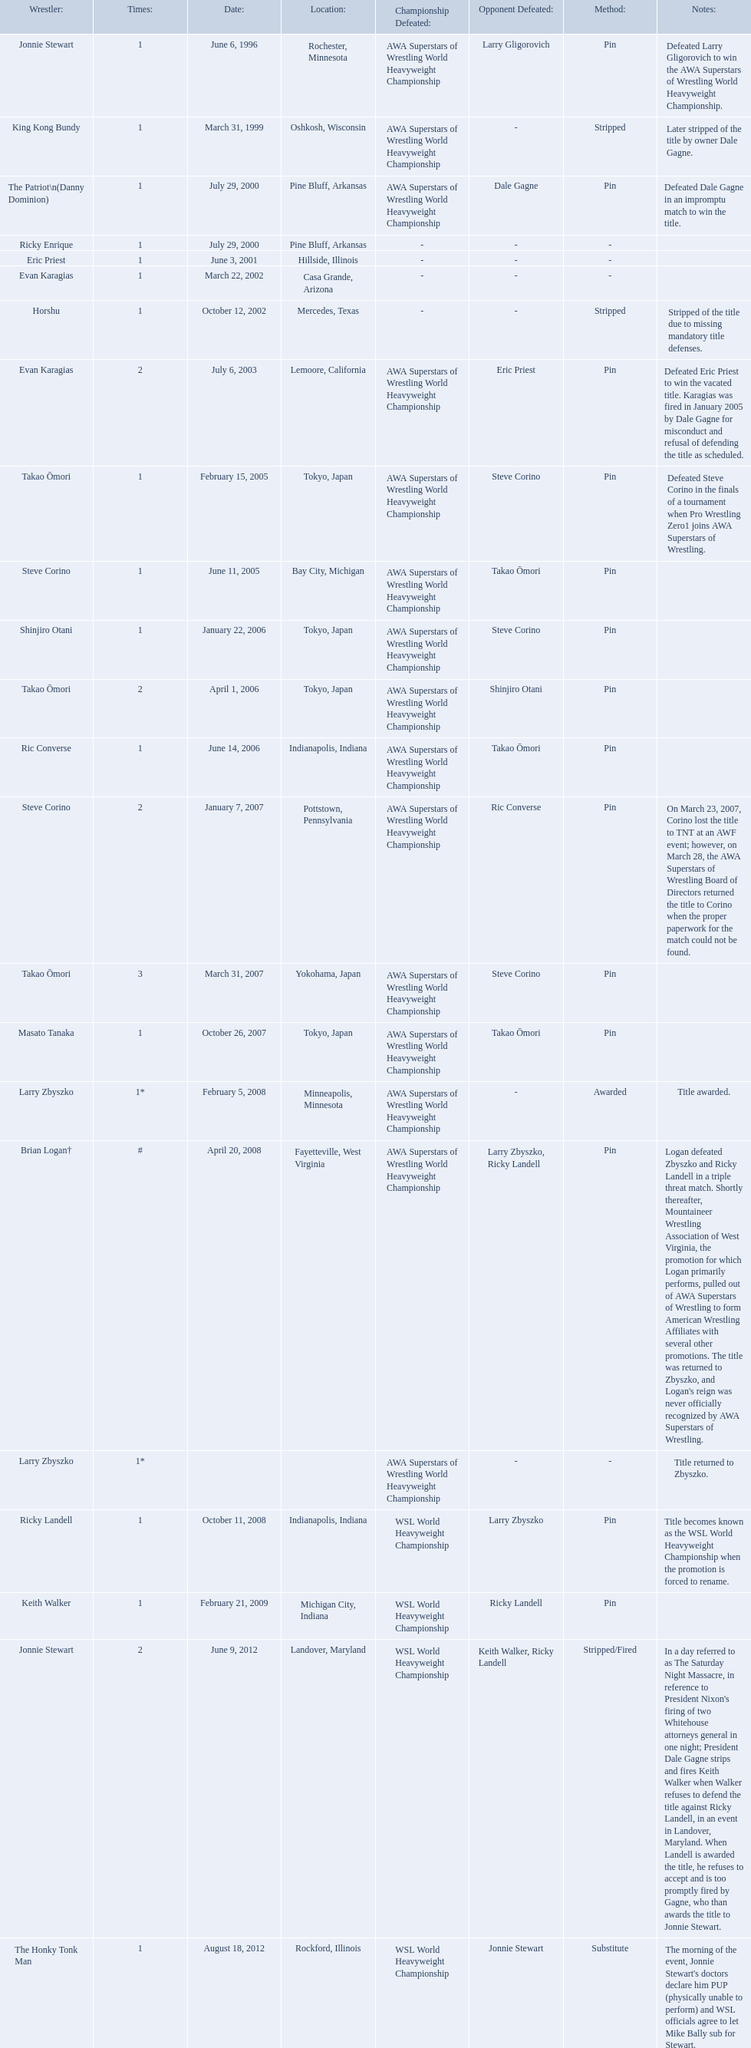Who are all of the wrestlers? Jonnie Stewart, King Kong Bundy, The Patriot\n(Danny Dominion), Ricky Enrique, Eric Priest, Evan Karagias, Horshu, Evan Karagias, Takao Ōmori, Steve Corino, Shinjiro Otani, Takao Ōmori, Ric Converse, Steve Corino, Takao Ōmori, Masato Tanaka, Larry Zbyszko, Brian Logan†, Larry Zbyszko, Ricky Landell, Keith Walker, Jonnie Stewart, The Honky Tonk Man. Where are they from? Rochester, Minnesota, Oshkosh, Wisconsin, Pine Bluff, Arkansas, Pine Bluff, Arkansas, Hillside, Illinois, Casa Grande, Arizona, Mercedes, Texas, Lemoore, California, Tokyo, Japan, Bay City, Michigan, Tokyo, Japan, Tokyo, Japan, Indianapolis, Indiana, Pottstown, Pennsylvania, Yokohama, Japan, Tokyo, Japan, Minneapolis, Minnesota, Fayetteville, West Virginia, , Indianapolis, Indiana, Michigan City, Indiana, Landover, Maryland, Rockford, Illinois. Could you help me parse every detail presented in this table? {'header': ['Wrestler:', 'Times:', 'Date:', 'Location:', 'Championship Defeated:', 'Opponent Defeated:', 'Method:', 'Notes:'], 'rows': [['Jonnie Stewart', '1', 'June 6, 1996', 'Rochester, Minnesota', 'AWA Superstars of Wrestling World Heavyweight Championship', 'Larry Gligorovich', 'Pin', 'Defeated Larry Gligorovich to win the AWA Superstars of Wrestling World Heavyweight Championship.'], ['King Kong Bundy', '1', 'March 31, 1999', 'Oshkosh, Wisconsin', 'AWA Superstars of Wrestling World Heavyweight Championship', '-', 'Stripped', 'Later stripped of the title by owner Dale Gagne.'], ['The Patriot\\n(Danny Dominion)', '1', 'July 29, 2000', 'Pine Bluff, Arkansas', 'AWA Superstars of Wrestling World Heavyweight Championship', 'Dale Gagne', 'Pin', 'Defeated Dale Gagne in an impromptu match to win the title.'], ['Ricky Enrique', '1', 'July 29, 2000', 'Pine Bluff, Arkansas', '-', '-', '-', ''], ['Eric Priest', '1', 'June 3, 2001', 'Hillside, Illinois', '-', '-', '-', ''], ['Evan Karagias', '1', 'March 22, 2002', 'Casa Grande, Arizona', '-', '-', '-', ''], ['Horshu', '1', 'October 12, 2002', 'Mercedes, Texas', '-', '-', 'Stripped', 'Stripped of the title due to missing mandatory title defenses.'], ['Evan Karagias', '2', 'July 6, 2003', 'Lemoore, California', 'AWA Superstars of Wrestling World Heavyweight Championship', 'Eric Priest', 'Pin', 'Defeated Eric Priest to win the vacated title. Karagias was fired in January 2005 by Dale Gagne for misconduct and refusal of defending the title as scheduled.'], ['Takao Ōmori', '1', 'February 15, 2005', 'Tokyo, Japan', 'AWA Superstars of Wrestling World Heavyweight Championship', 'Steve Corino', 'Pin', 'Defeated Steve Corino in the finals of a tournament when Pro Wrestling Zero1 joins AWA Superstars of Wrestling.'], ['Steve Corino', '1', 'June 11, 2005', 'Bay City, Michigan', 'AWA Superstars of Wrestling World Heavyweight Championship', 'Takao Ōmori', 'Pin', ''], ['Shinjiro Otani', '1', 'January 22, 2006', 'Tokyo, Japan', 'AWA Superstars of Wrestling World Heavyweight Championship', 'Steve Corino', 'Pin', ''], ['Takao Ōmori', '2', 'April 1, 2006', 'Tokyo, Japan', 'AWA Superstars of Wrestling World Heavyweight Championship', 'Shinjiro Otani', 'Pin', ''], ['Ric Converse', '1', 'June 14, 2006', 'Indianapolis, Indiana', 'AWA Superstars of Wrestling World Heavyweight Championship', 'Takao Ōmori', 'Pin', ''], ['Steve Corino', '2', 'January 7, 2007', 'Pottstown, Pennsylvania', 'AWA Superstars of Wrestling World Heavyweight Championship', 'Ric Converse', 'Pin', 'On March 23, 2007, Corino lost the title to TNT at an AWF event; however, on March 28, the AWA Superstars of Wrestling Board of Directors returned the title to Corino when the proper paperwork for the match could not be found.'], ['Takao Ōmori', '3', 'March 31, 2007', 'Yokohama, Japan', 'AWA Superstars of Wrestling World Heavyweight Championship', 'Steve Corino', 'Pin', ''], ['Masato Tanaka', '1', 'October 26, 2007', 'Tokyo, Japan', 'AWA Superstars of Wrestling World Heavyweight Championship', 'Takao Ōmori', 'Pin', ''], ['Larry Zbyszko', '1*', 'February 5, 2008', 'Minneapolis, Minnesota', 'AWA Superstars of Wrestling World Heavyweight Championship', '-', 'Awarded', 'Title awarded.'], ['Brian Logan†', '#', 'April 20, 2008', 'Fayetteville, West Virginia', 'AWA Superstars of Wrestling World Heavyweight Championship', 'Larry Zbyszko, Ricky Landell', 'Pin', "Logan defeated Zbyszko and Ricky Landell in a triple threat match. Shortly thereafter, Mountaineer Wrestling Association of West Virginia, the promotion for which Logan primarily performs, pulled out of AWA Superstars of Wrestling to form American Wrestling Affiliates with several other promotions. The title was returned to Zbyszko, and Logan's reign was never officially recognized by AWA Superstars of Wrestling."], ['Larry Zbyszko', '1*', '', '', 'AWA Superstars of Wrestling World Heavyweight Championship', '-', '-', 'Title returned to Zbyszko.'], ['Ricky Landell', '1', 'October 11, 2008', 'Indianapolis, Indiana', 'WSL World Heavyweight Championship', 'Larry Zbyszko', 'Pin', 'Title becomes known as the WSL World Heavyweight Championship when the promotion is forced to rename.'], ['Keith Walker', '1', 'February 21, 2009', 'Michigan City, Indiana', 'WSL World Heavyweight Championship', 'Ricky Landell', 'Pin', ''], ['Jonnie Stewart', '2', 'June 9, 2012', 'Landover, Maryland', 'WSL World Heavyweight Championship', 'Keith Walker, Ricky Landell', 'Stripped/Fired', "In a day referred to as The Saturday Night Massacre, in reference to President Nixon's firing of two Whitehouse attorneys general in one night; President Dale Gagne strips and fires Keith Walker when Walker refuses to defend the title against Ricky Landell, in an event in Landover, Maryland. When Landell is awarded the title, he refuses to accept and is too promptly fired by Gagne, who than awards the title to Jonnie Stewart."], ['The Honky Tonk Man', '1', 'August 18, 2012', 'Rockford, Illinois', 'WSL World Heavyweight Championship', 'Jonnie Stewart', 'Substitute', "The morning of the event, Jonnie Stewart's doctors declare him PUP (physically unable to perform) and WSL officials agree to let Mike Bally sub for Stewart."]]} And which of them is from texas? Horshu. Where are the title holders from? Rochester, Minnesota, Oshkosh, Wisconsin, Pine Bluff, Arkansas, Pine Bluff, Arkansas, Hillside, Illinois, Casa Grande, Arizona, Mercedes, Texas, Lemoore, California, Tokyo, Japan, Bay City, Michigan, Tokyo, Japan, Tokyo, Japan, Indianapolis, Indiana, Pottstown, Pennsylvania, Yokohama, Japan, Tokyo, Japan, Minneapolis, Minnesota, Fayetteville, West Virginia, , Indianapolis, Indiana, Michigan City, Indiana, Landover, Maryland, Rockford, Illinois. Who is the title holder from texas? Horshu. 